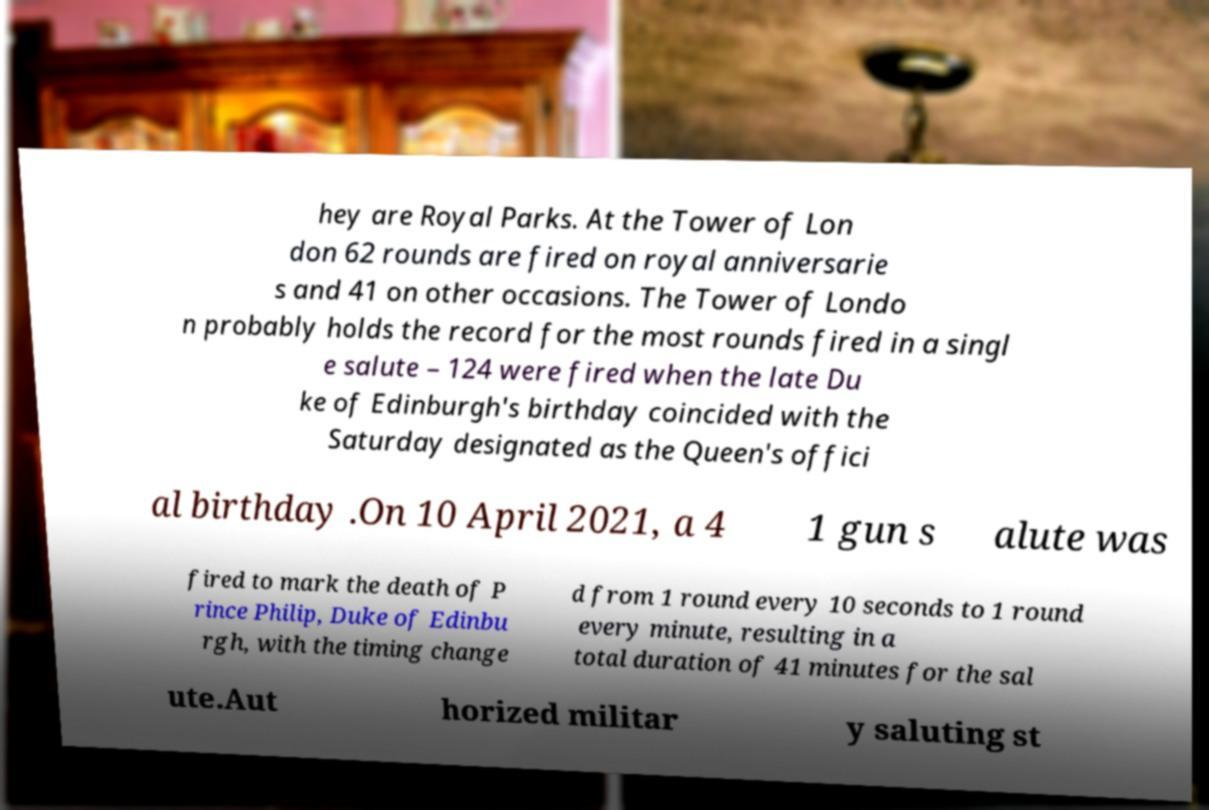Please identify and transcribe the text found in this image. hey are Royal Parks. At the Tower of Lon don 62 rounds are fired on royal anniversarie s and 41 on other occasions. The Tower of Londo n probably holds the record for the most rounds fired in a singl e salute – 124 were fired when the late Du ke of Edinburgh's birthday coincided with the Saturday designated as the Queen's offici al birthday .On 10 April 2021, a 4 1 gun s alute was fired to mark the death of P rince Philip, Duke of Edinbu rgh, with the timing change d from 1 round every 10 seconds to 1 round every minute, resulting in a total duration of 41 minutes for the sal ute.Aut horized militar y saluting st 